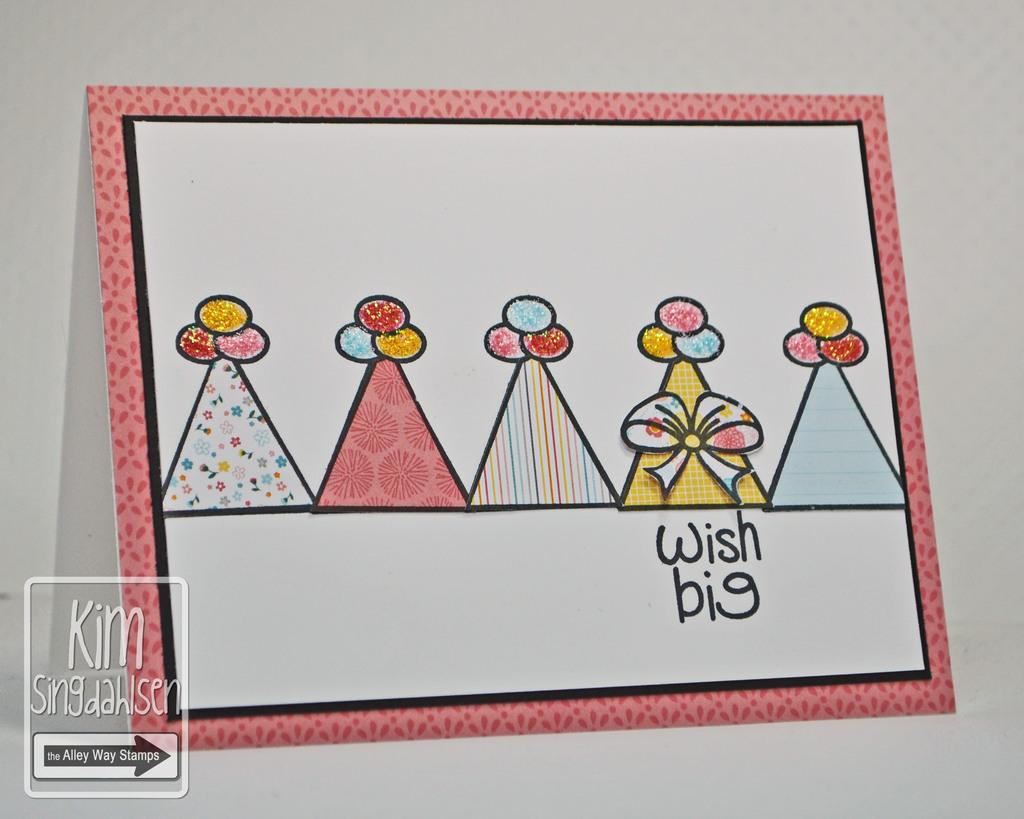What type of content is featured in the image? The image contains art. Can you describe any specific details about the art? There is text present on the art. Where is the logo located in the image? The logo is at the bottom left corner of the image. What color is the background of the image? The background of the image is white. What type of pipe is depicted in the image? There is no pipe present in the image; it contains art with text and a logo. Can you tell me what the artist was thinking while creating the art in the image? We cannot determine the artist's thoughts while creating the art from the image alone. 